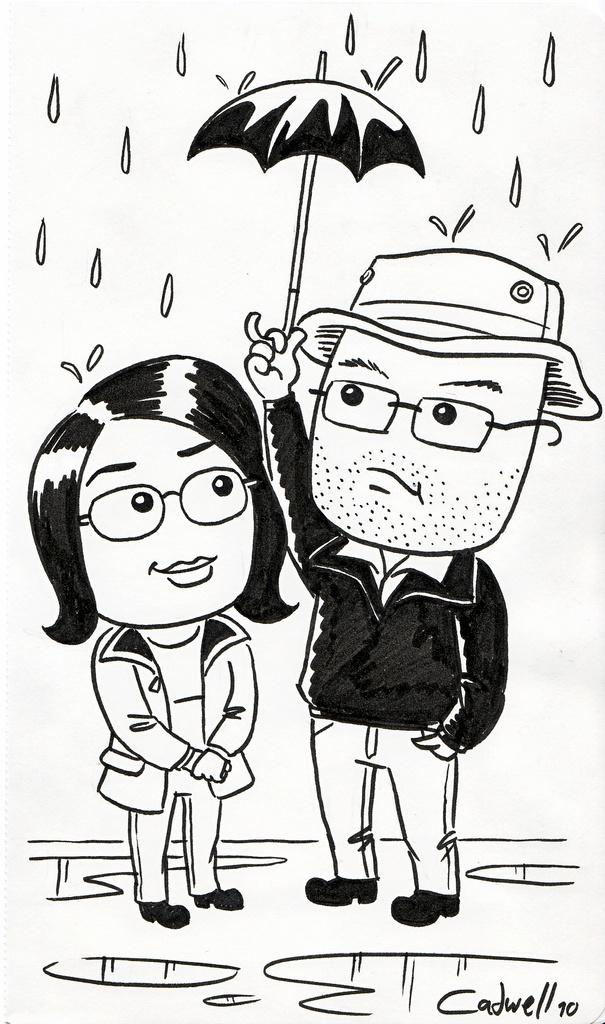How many people are in the image? There are two persons in the image. What is one person doing in the image? One person is holding an umbrella. What is the weather like in the image? It is raining in the image. What type of fireman is present in the image? There is no fireman present in the image. How does the rain sort itself in the image? The rain does not sort itself in the image; it falls naturally from the sky. 